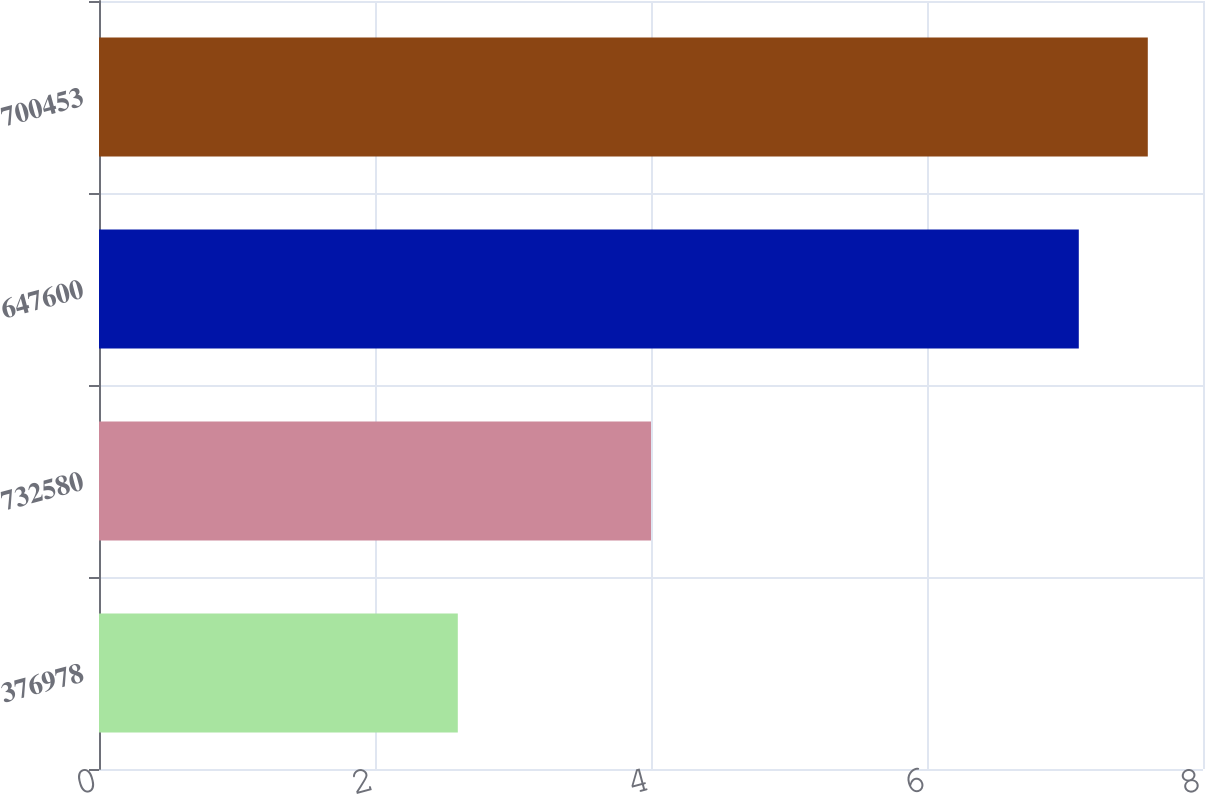Convert chart to OTSL. <chart><loc_0><loc_0><loc_500><loc_500><bar_chart><fcel>376978<fcel>732580<fcel>647600<fcel>700453<nl><fcel>2.6<fcel>4<fcel>7.1<fcel>7.6<nl></chart> 